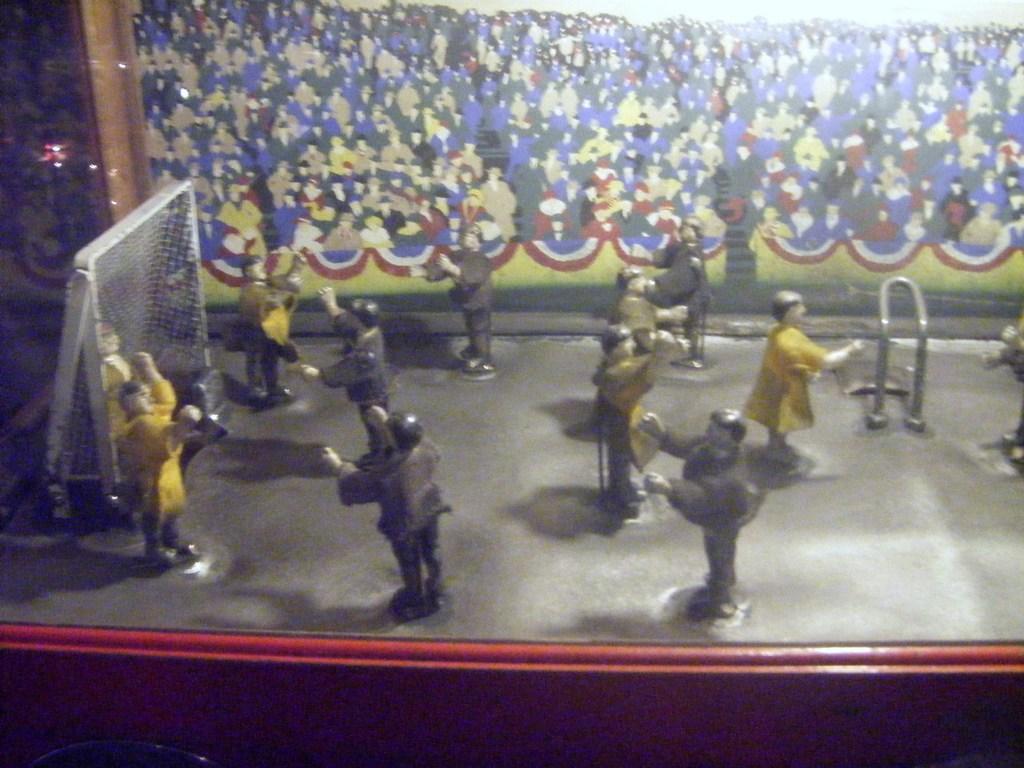Can you describe this image briefly? In this picture there are few toys and there is a net in the left corner and there is a painting in the background. 